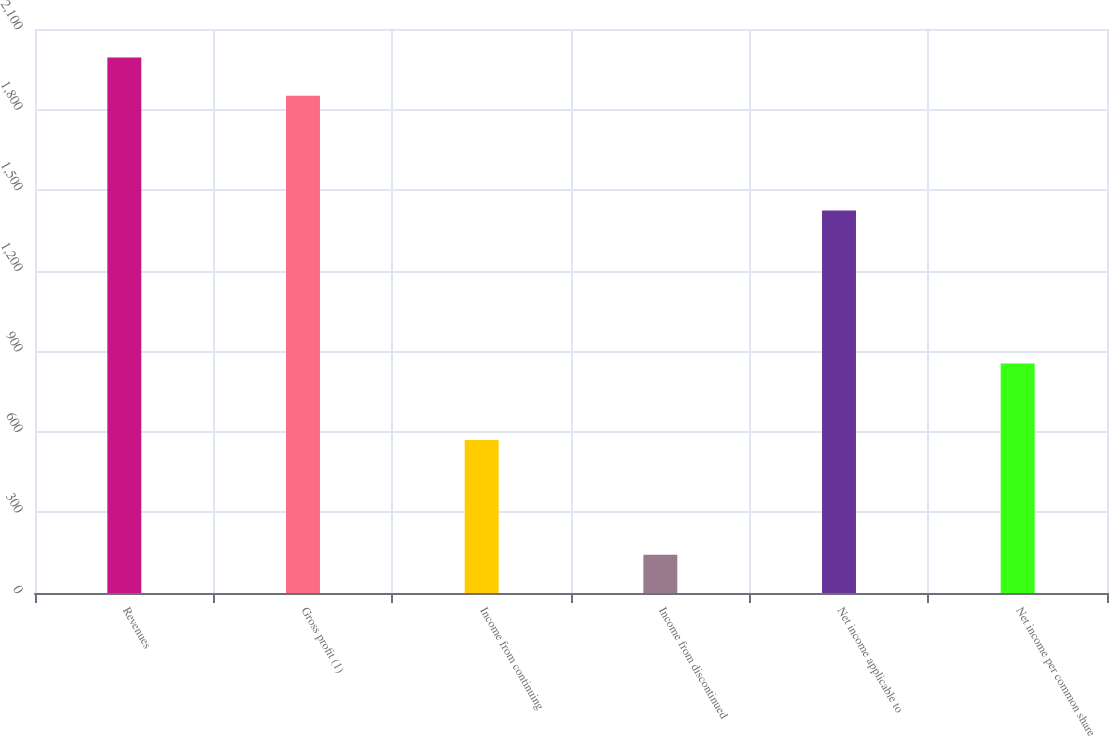Convert chart. <chart><loc_0><loc_0><loc_500><loc_500><bar_chart><fcel>Revenues<fcel>Gross profit (1)<fcel>Income from continuing<fcel>Income from discontinued<fcel>Net income applicable to<fcel>Net income per common share<nl><fcel>1993.56<fcel>1851.17<fcel>569.66<fcel>142.49<fcel>1424<fcel>854.44<nl></chart> 